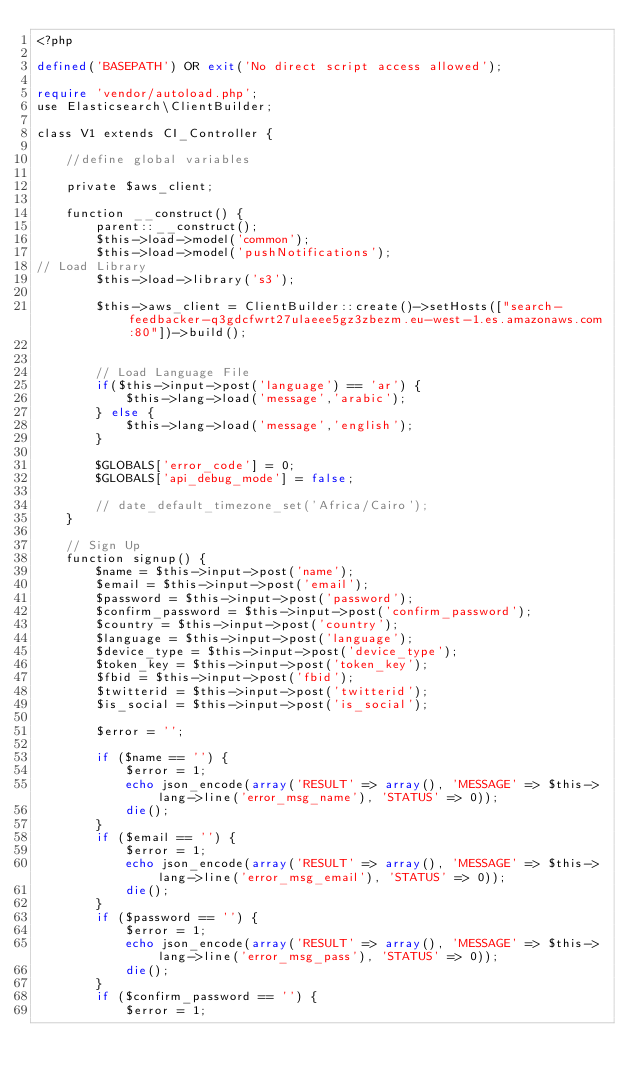Convert code to text. <code><loc_0><loc_0><loc_500><loc_500><_PHP_><?php

defined('BASEPATH') OR exit('No direct script access allowed');

require 'vendor/autoload.php';
use Elasticsearch\ClientBuilder;

class V1 extends CI_Controller {

    //define global variables

    private $aws_client;

    function __construct() {
        parent::__construct();
        $this->load->model('common');
        $this->load->model('pushNotifications');    
// Load Library
        $this->load->library('s3'); 
		
        $this->aws_client = ClientBuilder::create()->setHosts(["search-feedbacker-q3gdcfwrt27ulaeee5gz3zbezm.eu-west-1.es.amazonaws.com:80"])->build();  

        
        // Load Language File       
        if($this->input->post('language') == 'ar') {
            $this->lang->load('message','arabic');
        } else {
            $this->lang->load('message','english');
        }

        $GLOBALS['error_code'] = 0;
        $GLOBALS['api_debug_mode'] = false;

        // date_default_timezone_set('Africa/Cairo');
    }

    // Sign Up
    function signup() {
        $name = $this->input->post('name');
        $email = $this->input->post('email');
        $password = $this->input->post('password');
        $confirm_password = $this->input->post('confirm_password');
        $country = $this->input->post('country');
        $language = $this->input->post('language');
        $device_type = $this->input->post('device_type');
        $token_key = $this->input->post('token_key');
        $fbid = $this->input->post('fbid');
        $twitterid = $this->input->post('twitterid');
        $is_social = $this->input->post('is_social');

        $error = '';

        if ($name == '') {
            $error = 1;
            echo json_encode(array('RESULT' => array(), 'MESSAGE' => $this->lang->line('error_msg_name'), 'STATUS' => 0));
            die();
        }
        if ($email == '') {
            $error = 1;
            echo json_encode(array('RESULT' => array(), 'MESSAGE' => $this->lang->line('error_msg_email'), 'STATUS' => 0));
            die();
        }
        if ($password == '') {
            $error = 1;
            echo json_encode(array('RESULT' => array(), 'MESSAGE' => $this->lang->line('error_msg_pass'), 'STATUS' => 0));
            die();
        }
        if ($confirm_password == '') {
            $error = 1;</code> 